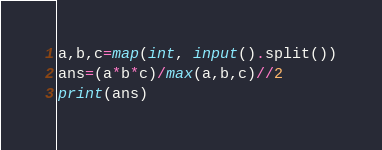Convert code to text. <code><loc_0><loc_0><loc_500><loc_500><_Python_>a,b,c=map(int, input().split())
ans=(a*b*c)/max(a,b,c)//2
print(ans)</code> 